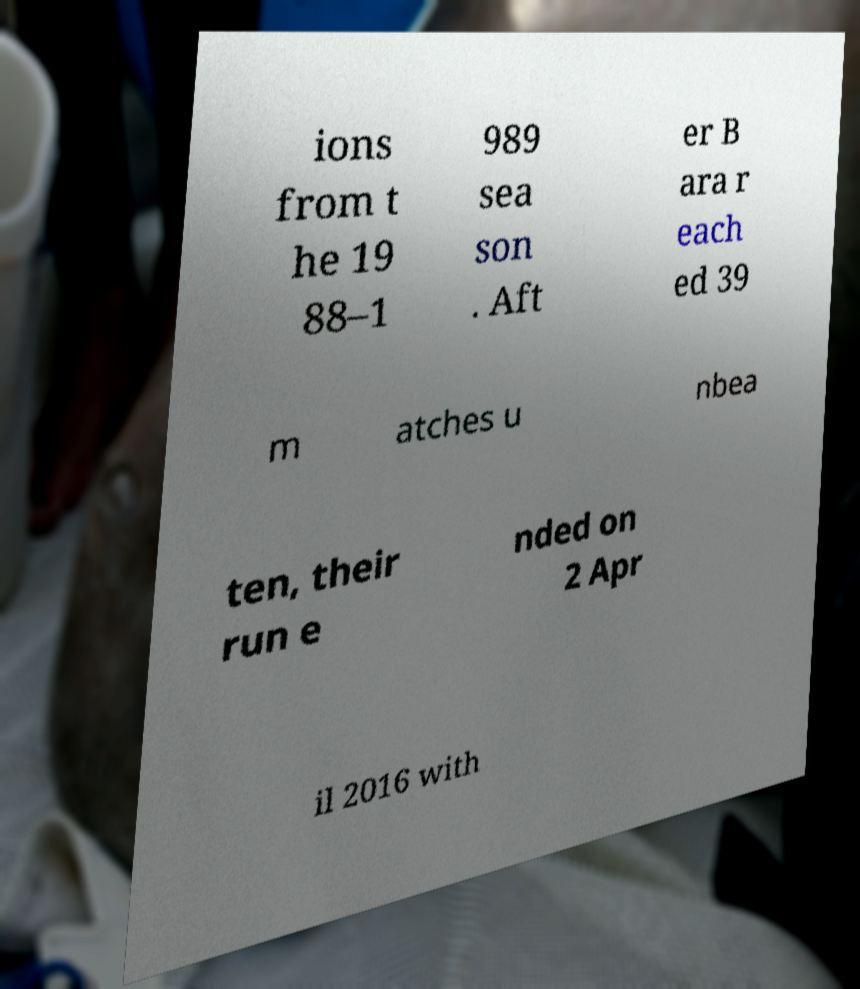Could you assist in decoding the text presented in this image and type it out clearly? ions from t he 19 88–1 989 sea son . Aft er B ara r each ed 39 m atches u nbea ten, their run e nded on 2 Apr il 2016 with 